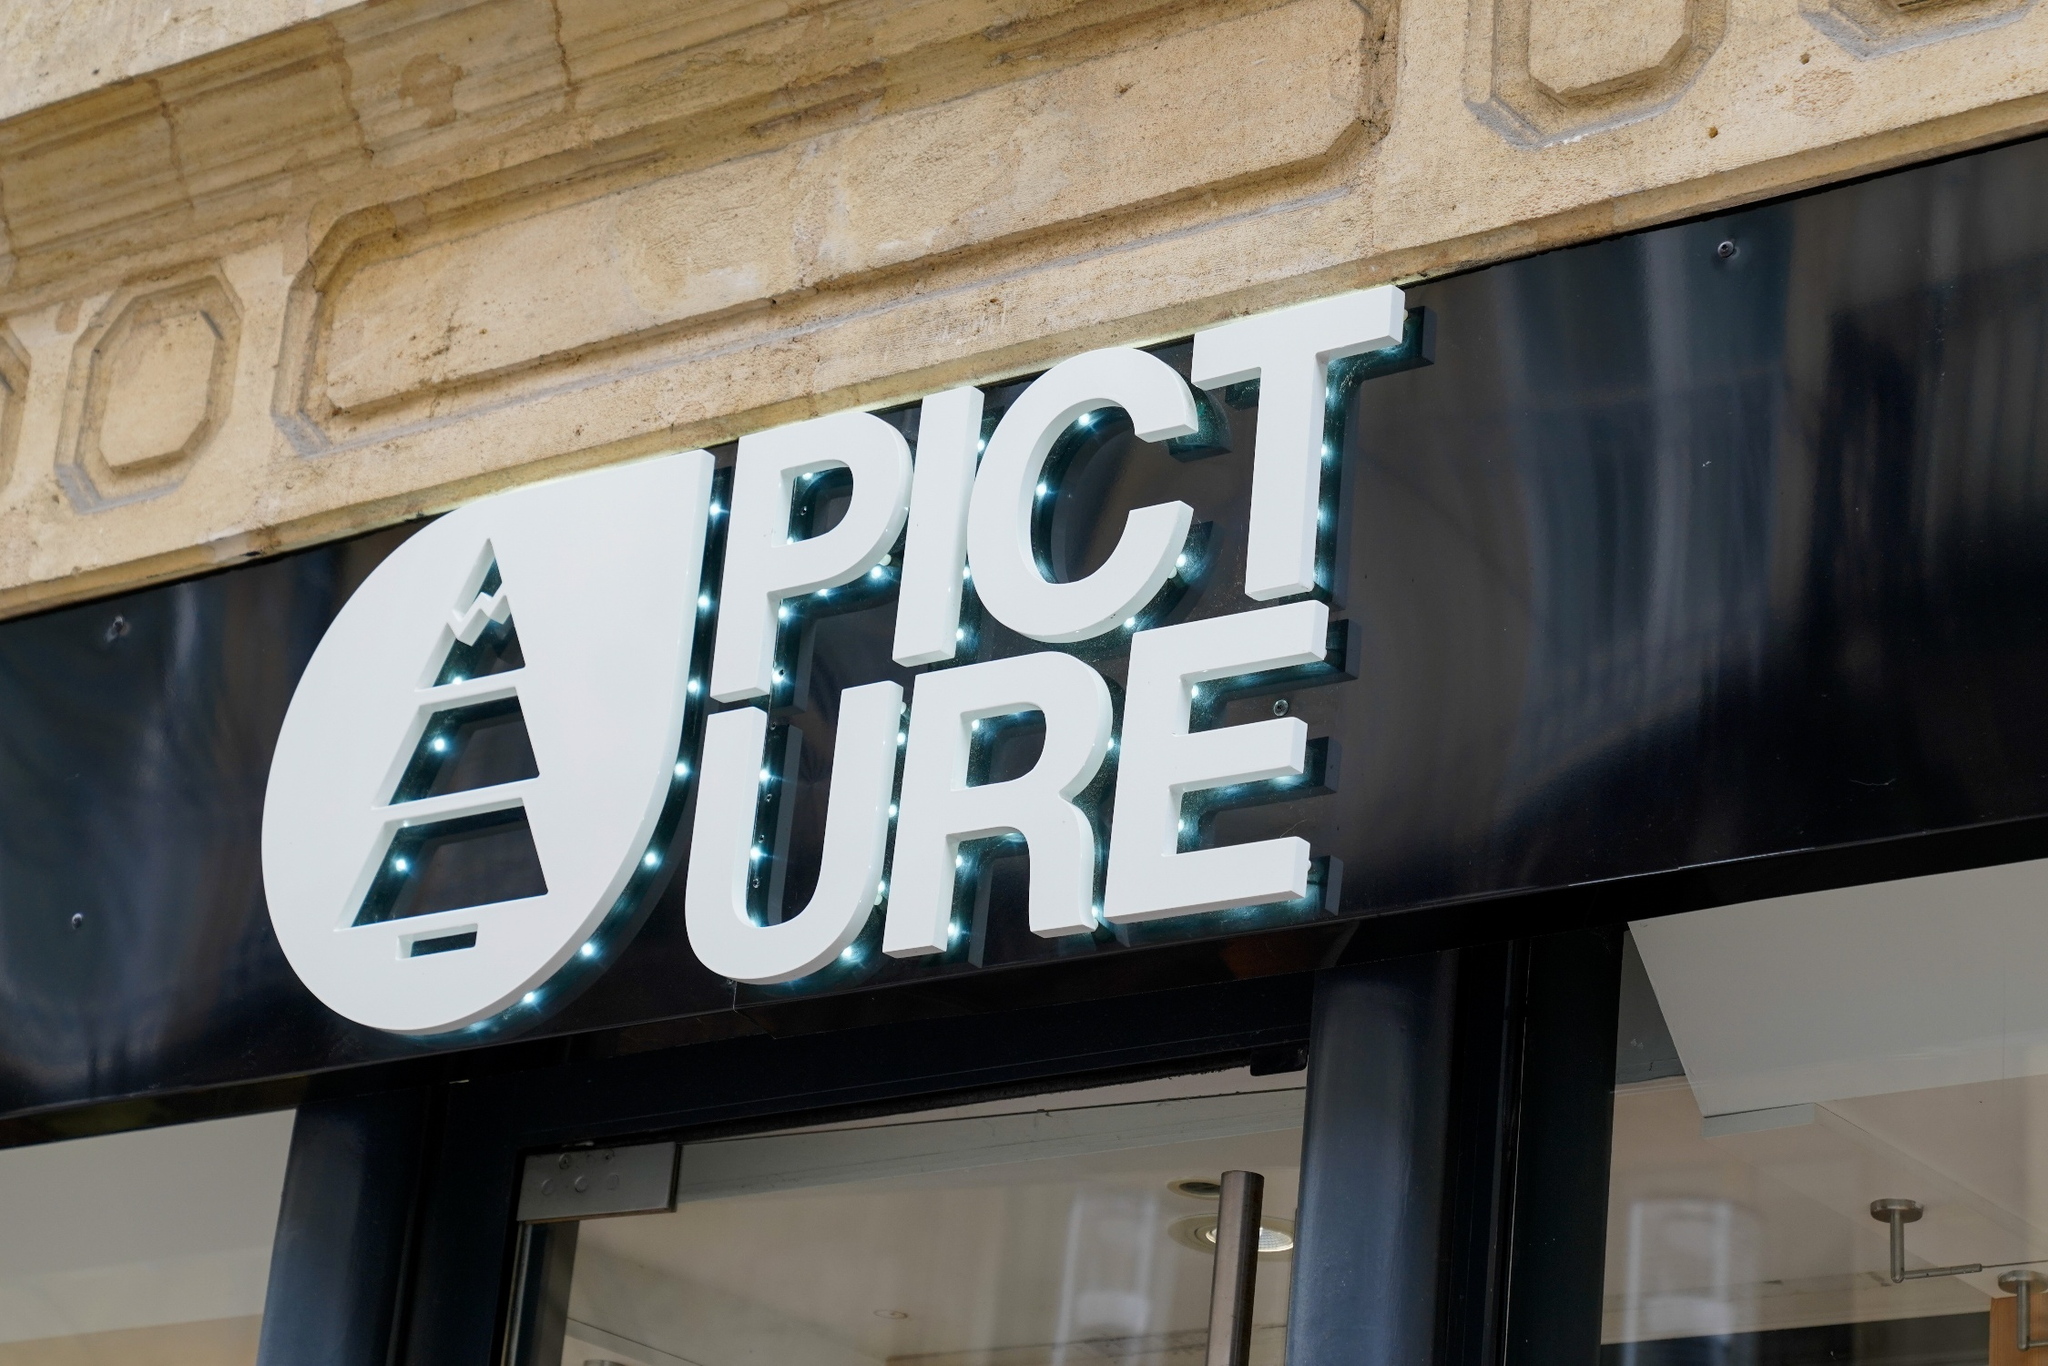Imagine this store as a person. Describe their character and appearance. If 'PICTURE' were a person, they would be someone with an artistic and refined demeanor. Dressed in smart, contemporary attire with a hint of vintage charm, they'd radiate confidence and style effortlessly. Their character would be approachable, cultured, and creative, always seeking to inspire and share their love for art and beauty with everyone they meet. They’d likely have a keen eye for detail, possessing a warm smile that invites conversations about their latest artistic ventures and exhibitions. Could you detail a day in the life of this personified store? A day in the life of 'PICTURE' personified would begin with an early morning routine of setting up their gallery, ensuring each photo is perfectly aligned and the lighting is just right. They open their doors with a welcoming smile, greeting early visitors with genuine enthusiasm. Throughout the day, they engage in meaningful conversations about art, sharing stories behind each photograph and recommending special pieces tailored to visitors' tastes. In the afternoon, they might host a small workshop, teaching budding photographers the nuances of capturing perfect shots. As evening approaches, they prepare for a cozy gallery show, transforming the space with ambient lighting and setting the mood for a night of artistic revelry. Their day ends with satisfaction, knowing they've touched the hearts of many through their passion for photography. 